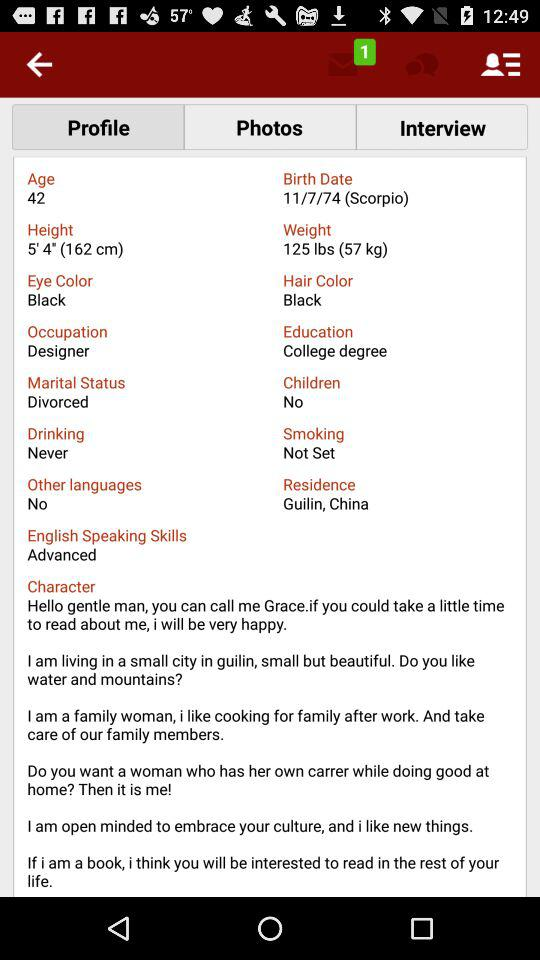What is the age? The age is 42 years. 